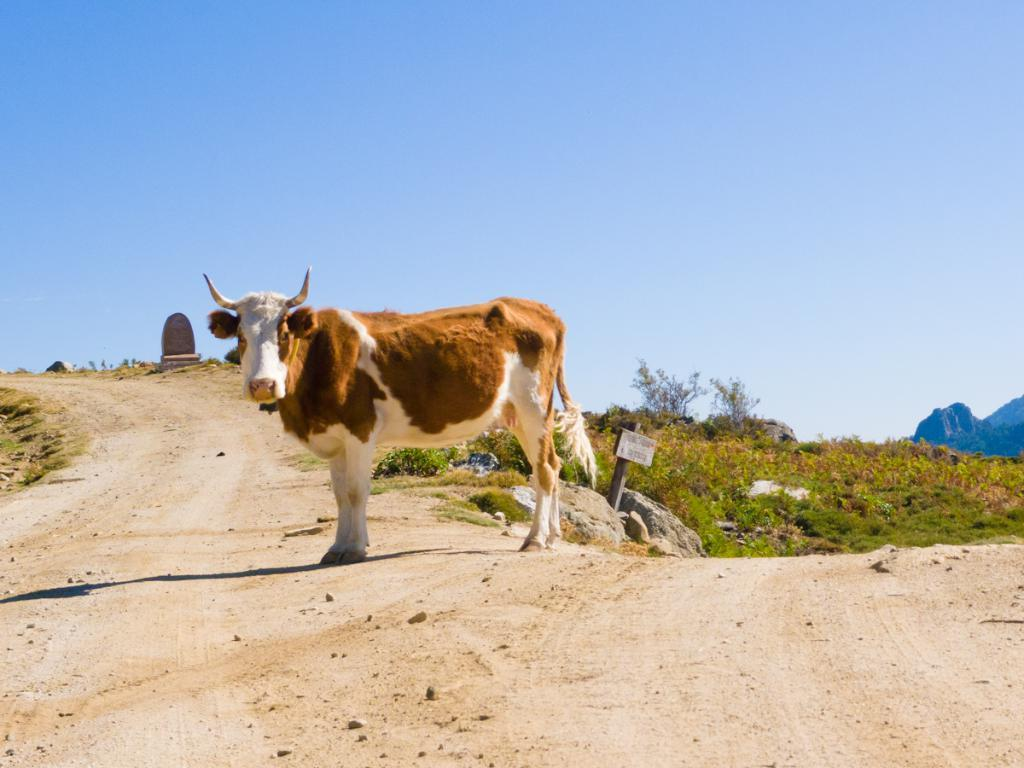What animal is on the ground in the image? There is a bull on the ground in the image. What can be seen in the background of the image? There are socks, grass, a wooden stick with a board, mountains, and the sky. What type of vegetation is present in the background of the image? There is grass in the background of the image. What type of structure is visible in the background of the image? There is a wooden stick with a board in the background of the image. What natural feature is visible in the background of the image? There are mountains in the background of the image. What is visible in the sky in the background of the image? The sky is visible in the background of the image. What type of vehicle is the bull driving in the image? There is no vehicle present in the image, and the bull is not driving anything. 